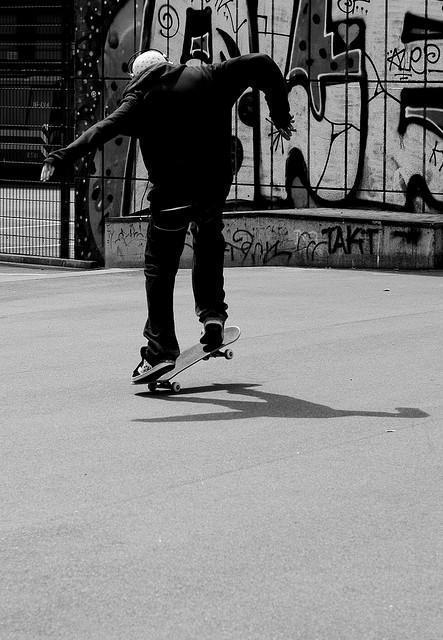How many chairs can you see that are empty?
Give a very brief answer. 0. 